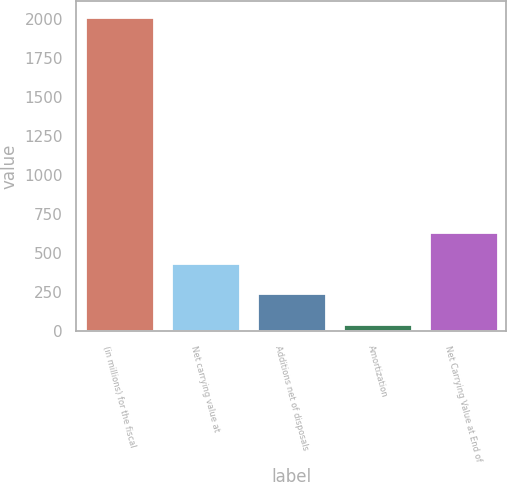Convert chart to OTSL. <chart><loc_0><loc_0><loc_500><loc_500><bar_chart><fcel>(in millions) for the fiscal<fcel>Net carrying value at<fcel>Additions net of disposals<fcel>Amortization<fcel>Net Carrying Value at End of<nl><fcel>2015<fcel>440.2<fcel>243.35<fcel>46.5<fcel>637.05<nl></chart> 